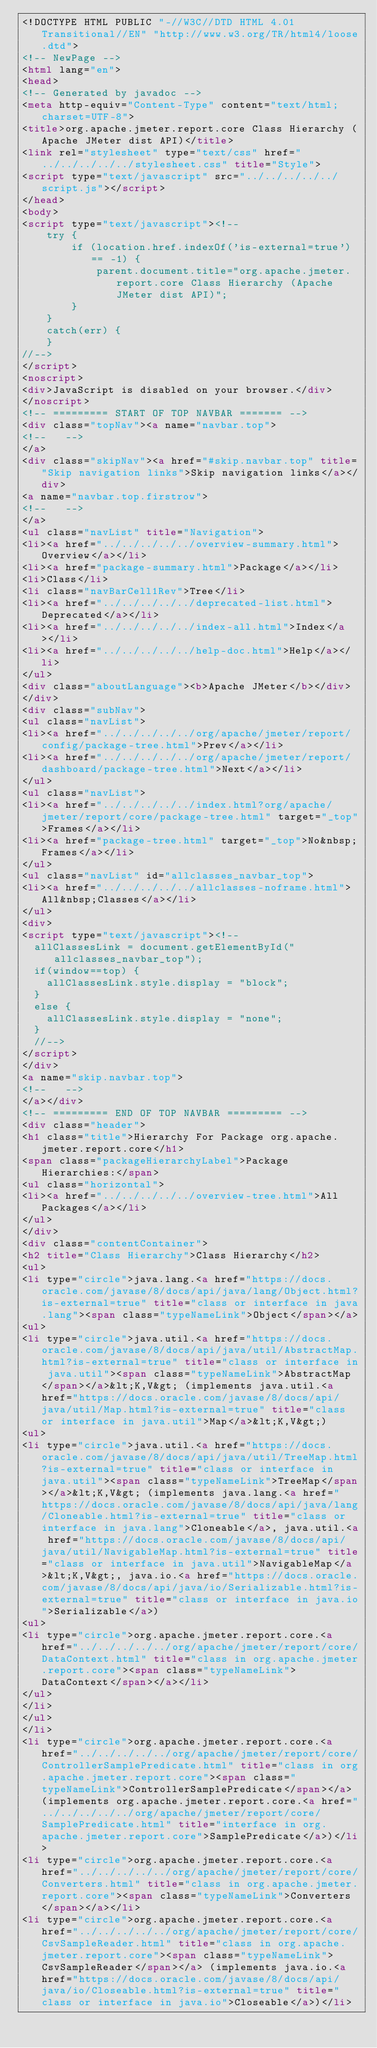Convert code to text. <code><loc_0><loc_0><loc_500><loc_500><_HTML_><!DOCTYPE HTML PUBLIC "-//W3C//DTD HTML 4.01 Transitional//EN" "http://www.w3.org/TR/html4/loose.dtd">
<!-- NewPage -->
<html lang="en">
<head>
<!-- Generated by javadoc -->
<meta http-equiv="Content-Type" content="text/html; charset=UTF-8">
<title>org.apache.jmeter.report.core Class Hierarchy (Apache JMeter dist API)</title>
<link rel="stylesheet" type="text/css" href="../../../../../stylesheet.css" title="Style">
<script type="text/javascript" src="../../../../../script.js"></script>
</head>
<body>
<script type="text/javascript"><!--
    try {
        if (location.href.indexOf('is-external=true') == -1) {
            parent.document.title="org.apache.jmeter.report.core Class Hierarchy (Apache JMeter dist API)";
        }
    }
    catch(err) {
    }
//-->
</script>
<noscript>
<div>JavaScript is disabled on your browser.</div>
</noscript>
<!-- ========= START OF TOP NAVBAR ======= -->
<div class="topNav"><a name="navbar.top">
<!--   -->
</a>
<div class="skipNav"><a href="#skip.navbar.top" title="Skip navigation links">Skip navigation links</a></div>
<a name="navbar.top.firstrow">
<!--   -->
</a>
<ul class="navList" title="Navigation">
<li><a href="../../../../../overview-summary.html">Overview</a></li>
<li><a href="package-summary.html">Package</a></li>
<li>Class</li>
<li class="navBarCell1Rev">Tree</li>
<li><a href="../../../../../deprecated-list.html">Deprecated</a></li>
<li><a href="../../../../../index-all.html">Index</a></li>
<li><a href="../../../../../help-doc.html">Help</a></li>
</ul>
<div class="aboutLanguage"><b>Apache JMeter</b></div>
</div>
<div class="subNav">
<ul class="navList">
<li><a href="../../../../../org/apache/jmeter/report/config/package-tree.html">Prev</a></li>
<li><a href="../../../../../org/apache/jmeter/report/dashboard/package-tree.html">Next</a></li>
</ul>
<ul class="navList">
<li><a href="../../../../../index.html?org/apache/jmeter/report/core/package-tree.html" target="_top">Frames</a></li>
<li><a href="package-tree.html" target="_top">No&nbsp;Frames</a></li>
</ul>
<ul class="navList" id="allclasses_navbar_top">
<li><a href="../../../../../allclasses-noframe.html">All&nbsp;Classes</a></li>
</ul>
<div>
<script type="text/javascript"><!--
  allClassesLink = document.getElementById("allclasses_navbar_top");
  if(window==top) {
    allClassesLink.style.display = "block";
  }
  else {
    allClassesLink.style.display = "none";
  }
  //-->
</script>
</div>
<a name="skip.navbar.top">
<!--   -->
</a></div>
<!-- ========= END OF TOP NAVBAR ========= -->
<div class="header">
<h1 class="title">Hierarchy For Package org.apache.jmeter.report.core</h1>
<span class="packageHierarchyLabel">Package Hierarchies:</span>
<ul class="horizontal">
<li><a href="../../../../../overview-tree.html">All Packages</a></li>
</ul>
</div>
<div class="contentContainer">
<h2 title="Class Hierarchy">Class Hierarchy</h2>
<ul>
<li type="circle">java.lang.<a href="https://docs.oracle.com/javase/8/docs/api/java/lang/Object.html?is-external=true" title="class or interface in java.lang"><span class="typeNameLink">Object</span></a>
<ul>
<li type="circle">java.util.<a href="https://docs.oracle.com/javase/8/docs/api/java/util/AbstractMap.html?is-external=true" title="class or interface in java.util"><span class="typeNameLink">AbstractMap</span></a>&lt;K,V&gt; (implements java.util.<a href="https://docs.oracle.com/javase/8/docs/api/java/util/Map.html?is-external=true" title="class or interface in java.util">Map</a>&lt;K,V&gt;)
<ul>
<li type="circle">java.util.<a href="https://docs.oracle.com/javase/8/docs/api/java/util/TreeMap.html?is-external=true" title="class or interface in java.util"><span class="typeNameLink">TreeMap</span></a>&lt;K,V&gt; (implements java.lang.<a href="https://docs.oracle.com/javase/8/docs/api/java/lang/Cloneable.html?is-external=true" title="class or interface in java.lang">Cloneable</a>, java.util.<a href="https://docs.oracle.com/javase/8/docs/api/java/util/NavigableMap.html?is-external=true" title="class or interface in java.util">NavigableMap</a>&lt;K,V&gt;, java.io.<a href="https://docs.oracle.com/javase/8/docs/api/java/io/Serializable.html?is-external=true" title="class or interface in java.io">Serializable</a>)
<ul>
<li type="circle">org.apache.jmeter.report.core.<a href="../../../../../org/apache/jmeter/report/core/DataContext.html" title="class in org.apache.jmeter.report.core"><span class="typeNameLink">DataContext</span></a></li>
</ul>
</li>
</ul>
</li>
<li type="circle">org.apache.jmeter.report.core.<a href="../../../../../org/apache/jmeter/report/core/ControllerSamplePredicate.html" title="class in org.apache.jmeter.report.core"><span class="typeNameLink">ControllerSamplePredicate</span></a> (implements org.apache.jmeter.report.core.<a href="../../../../../org/apache/jmeter/report/core/SamplePredicate.html" title="interface in org.apache.jmeter.report.core">SamplePredicate</a>)</li>
<li type="circle">org.apache.jmeter.report.core.<a href="../../../../../org/apache/jmeter/report/core/Converters.html" title="class in org.apache.jmeter.report.core"><span class="typeNameLink">Converters</span></a></li>
<li type="circle">org.apache.jmeter.report.core.<a href="../../../../../org/apache/jmeter/report/core/CsvSampleReader.html" title="class in org.apache.jmeter.report.core"><span class="typeNameLink">CsvSampleReader</span></a> (implements java.io.<a href="https://docs.oracle.com/javase/8/docs/api/java/io/Closeable.html?is-external=true" title="class or interface in java.io">Closeable</a>)</li></code> 